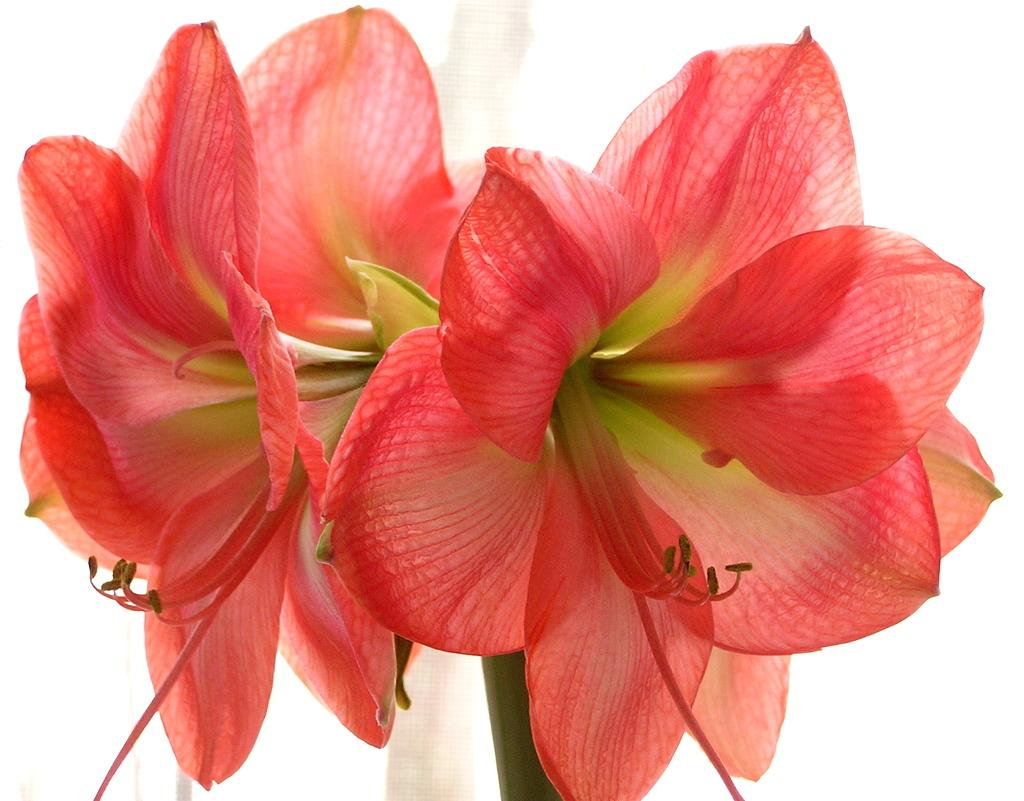What type of living organisms can be seen in the image? There are flowers in the image. What color is the background of the image? The background of the image is white. What type of toothpaste is being used by the representative in the image? There is no representative or toothpaste present in the image; it features flowers against a white background. 